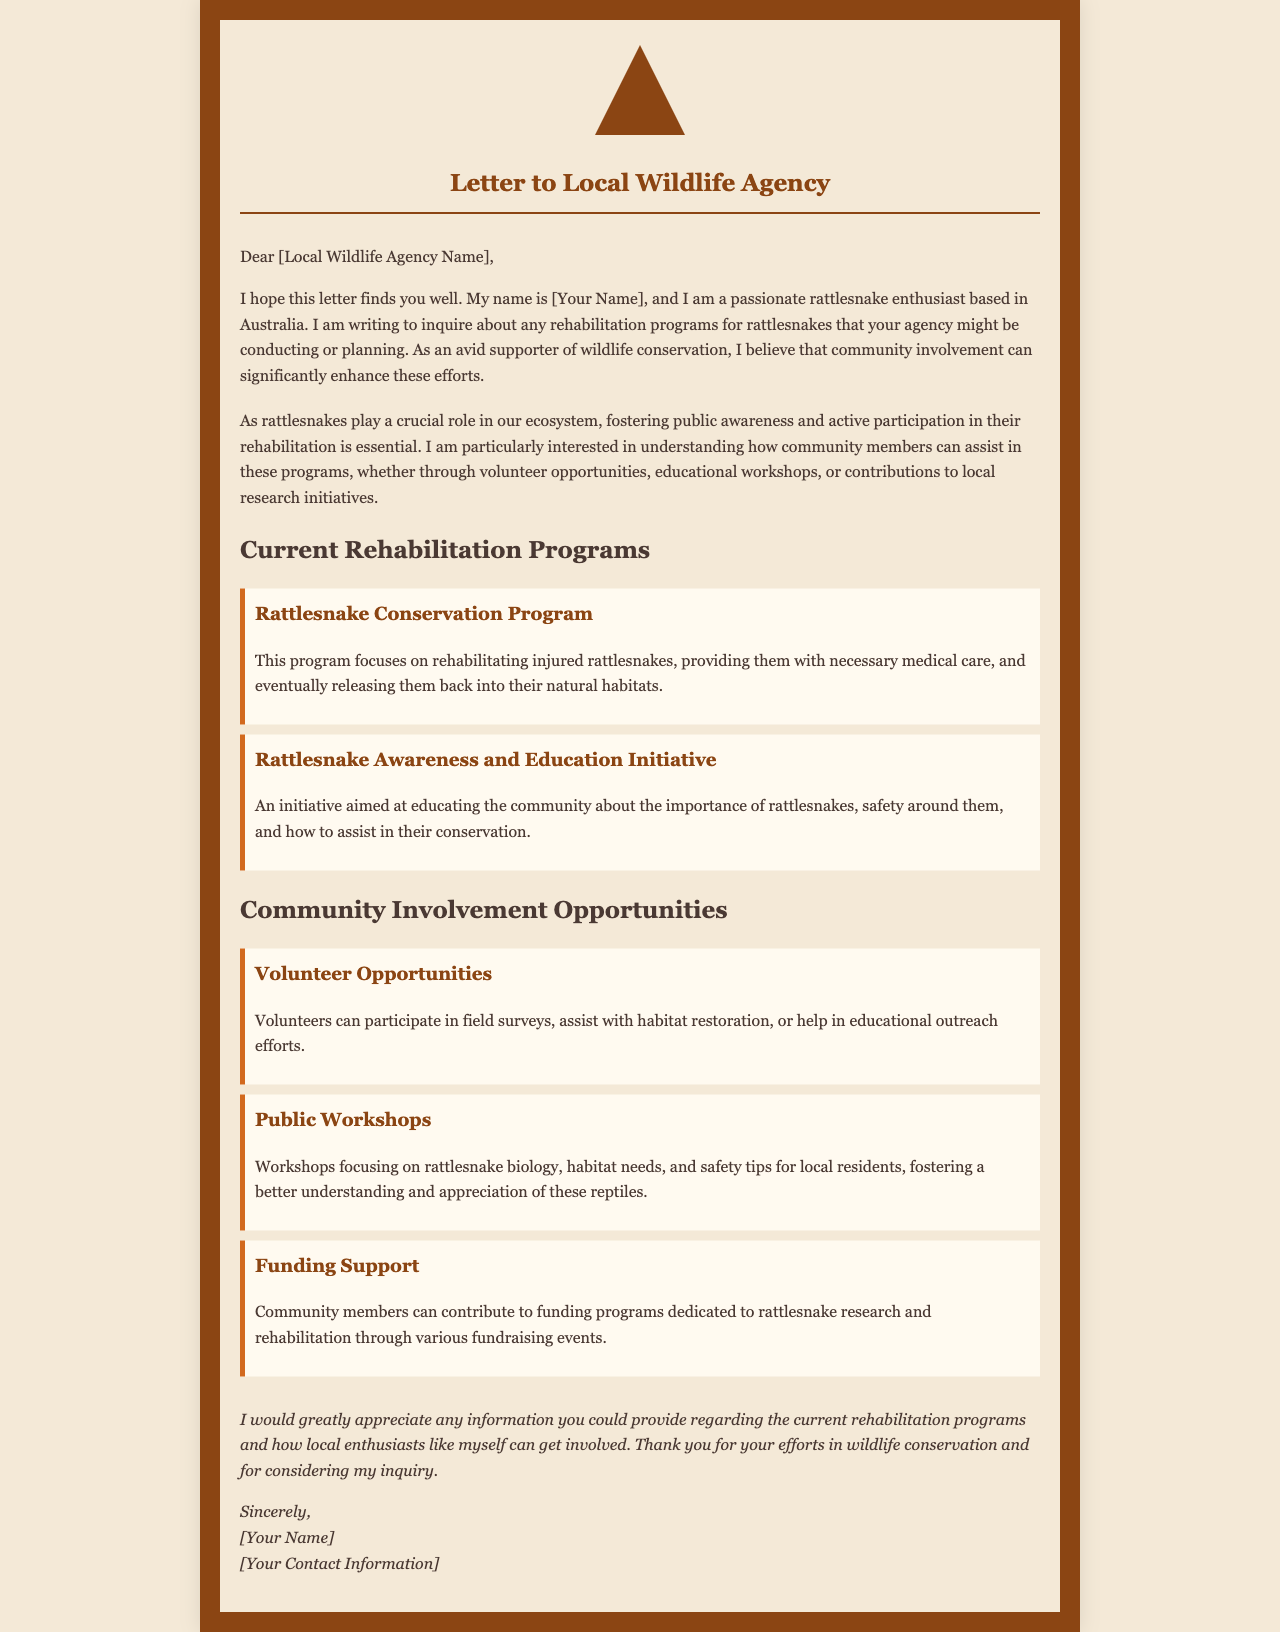What is the letter's main purpose? The main purpose of the letter is to inquire about rattlesnake rehabilitation programs and community involvement opportunities.
Answer: Inquire about rehabilitation programs Who is the author of the letter? The author is a rattlesnake enthusiast based in Australia, although their actual name is not provided.
Answer: [Your Name] What is one of the current rehabilitation programs mentioned? The letter lists specific programs related to rattlesnake rehabilitation; one such program is the Rattlesnake Conservation Program.
Answer: Rattlesnake Conservation Program What type of community opportunity involves participating in field surveys? The document mentions volunteer opportunities as a way for community members to be involved in various activities.
Answer: Volunteer Opportunities What is a key focus of the Rattlesnake Awareness and Education Initiative? The initiative aims to educate the community about the importance of rattlesnakes and safety around them.
Answer: Educating the community How can community members contribute financially? Community members can contribute to funding programs through various fundraising events.
Answer: Fundraising events What phrase describes the author’s sentiment towards wildlife conservation? The letter expresses a supportive attitude towards conservation efforts, highlighting community involvement as significant.
Answer: Passionate supporter What does the author request at the end of the letter? The author requests information regarding current rehabilitation programs and ways to get involved.
Answer: Information on programs and involvement 